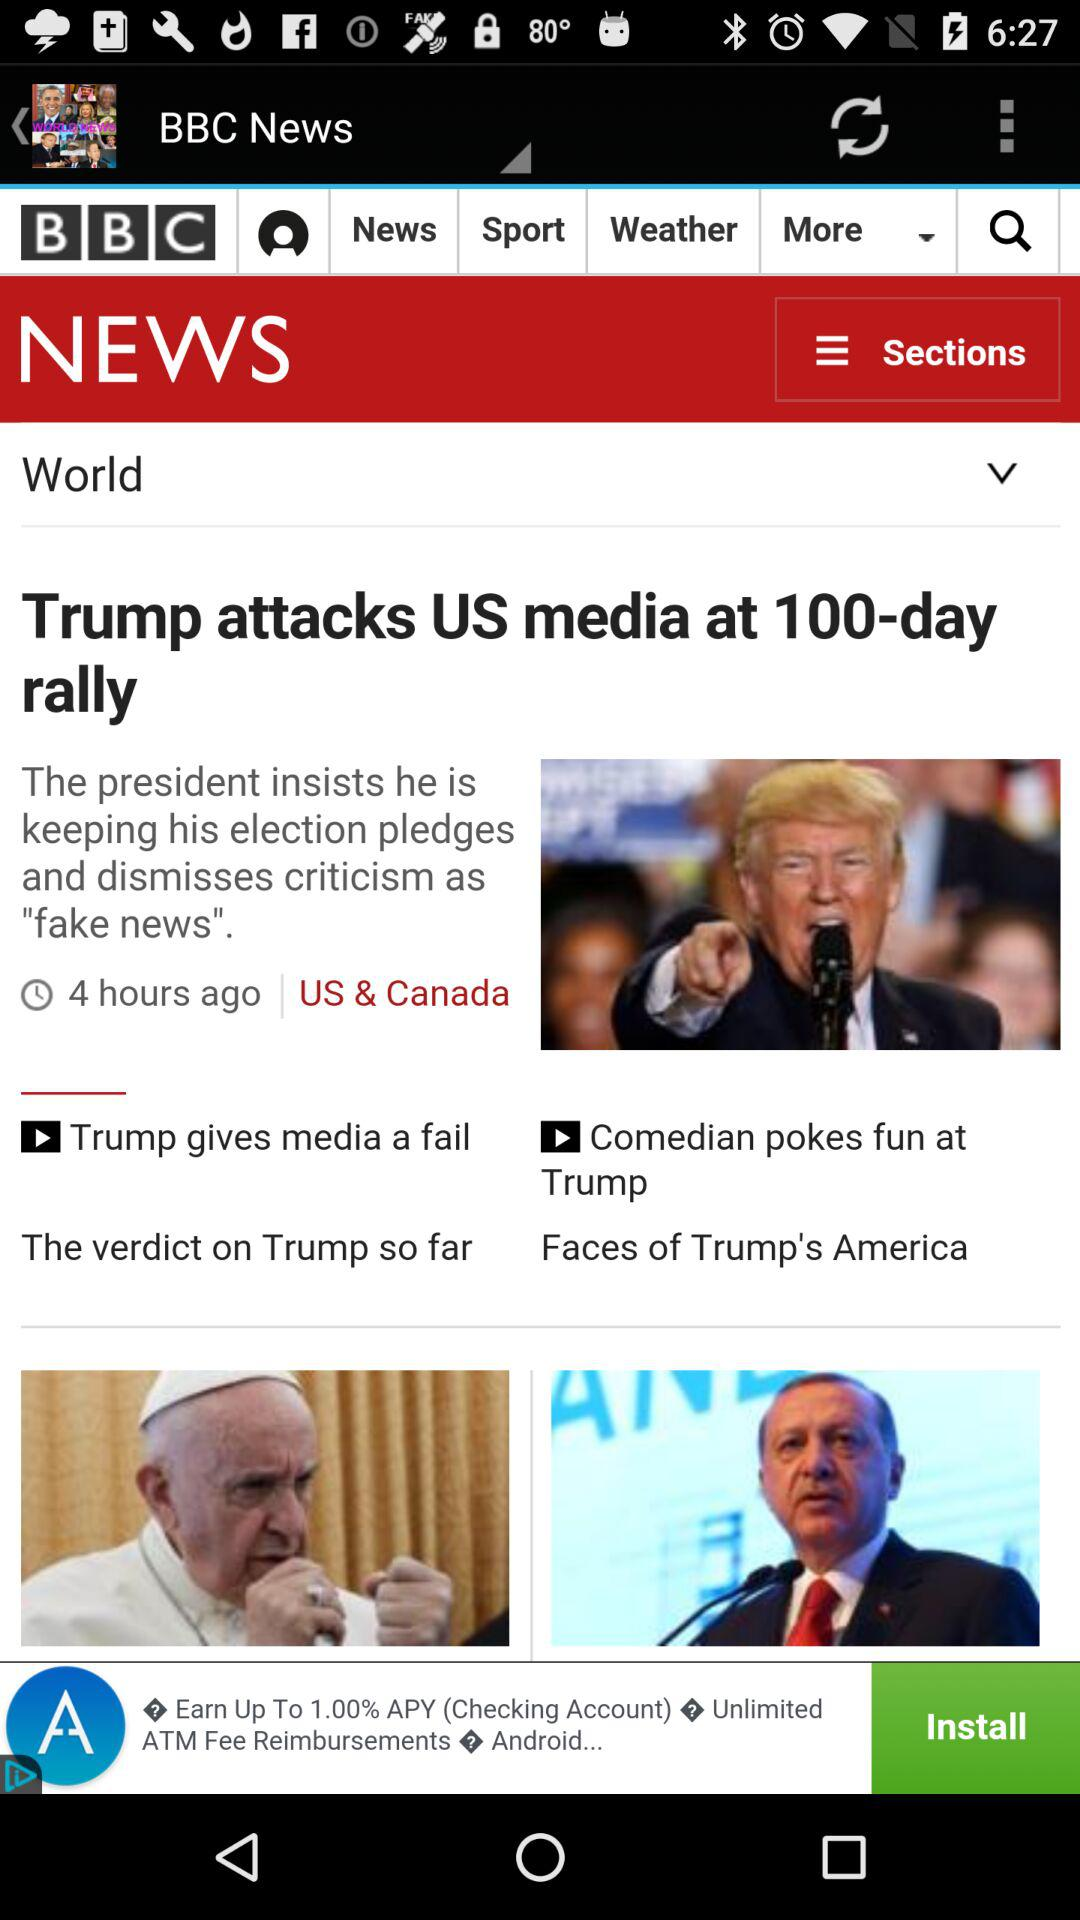What is the name of the application? The name of the application is "BBC News". 